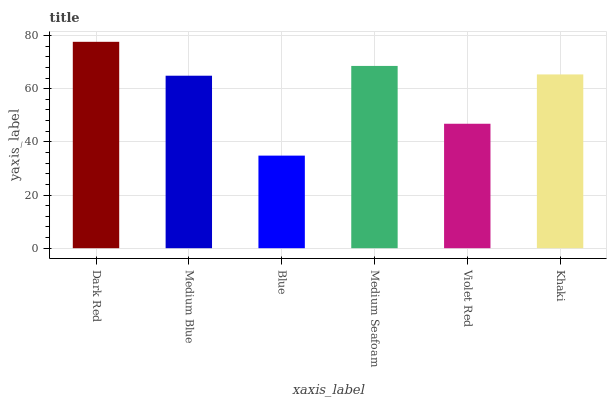Is Blue the minimum?
Answer yes or no. Yes. Is Dark Red the maximum?
Answer yes or no. Yes. Is Medium Blue the minimum?
Answer yes or no. No. Is Medium Blue the maximum?
Answer yes or no. No. Is Dark Red greater than Medium Blue?
Answer yes or no. Yes. Is Medium Blue less than Dark Red?
Answer yes or no. Yes. Is Medium Blue greater than Dark Red?
Answer yes or no. No. Is Dark Red less than Medium Blue?
Answer yes or no. No. Is Khaki the high median?
Answer yes or no. Yes. Is Medium Blue the low median?
Answer yes or no. Yes. Is Blue the high median?
Answer yes or no. No. Is Violet Red the low median?
Answer yes or no. No. 